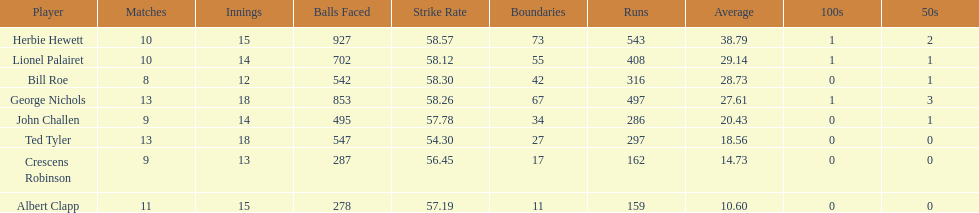What is the least about of runs anyone has? 159. 